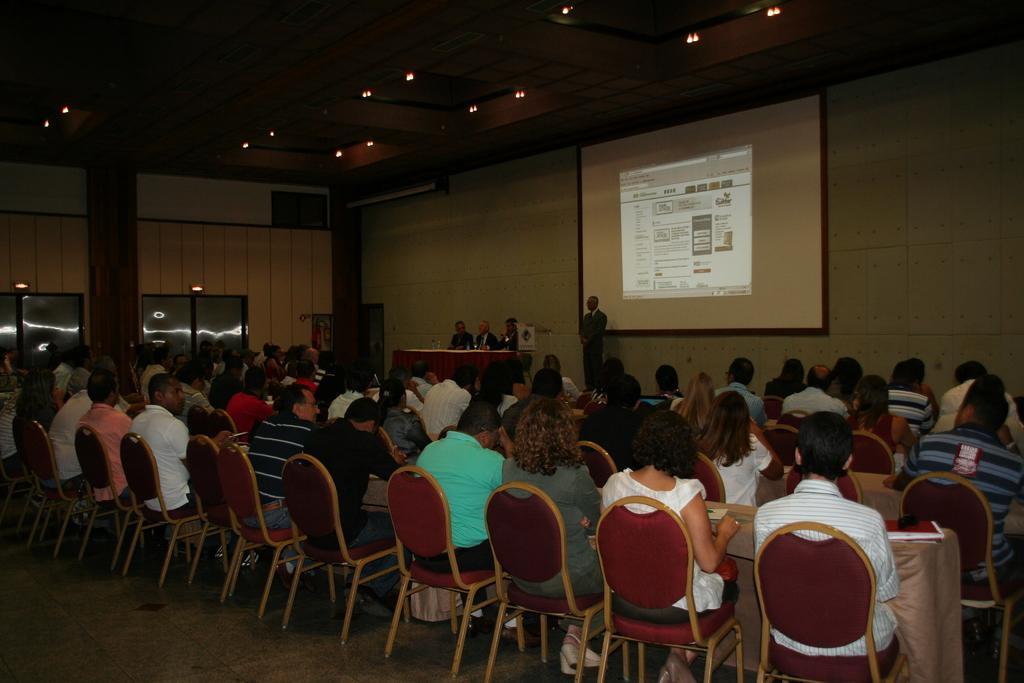Could you give a brief overview of what you see in this image? This picture is of inside the hall. In the foreground we can see group of persons sitting on the chairs and there is a table covered with a cloth and there is a book placed on the top of the table. In the background we can see some persons sitting on the chairs and there is a person standing and we can see a projector screen and a wall. 